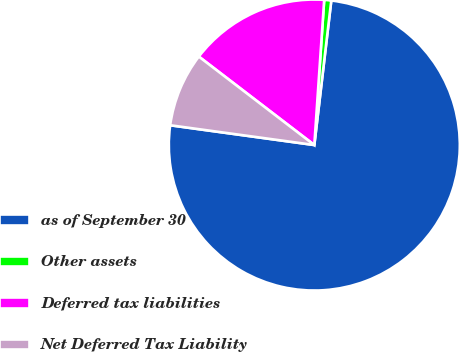Convert chart to OTSL. <chart><loc_0><loc_0><loc_500><loc_500><pie_chart><fcel>as of September 30<fcel>Other assets<fcel>Deferred tax liabilities<fcel>Net Deferred Tax Liability<nl><fcel>75.31%<fcel>0.78%<fcel>15.68%<fcel>8.23%<nl></chart> 